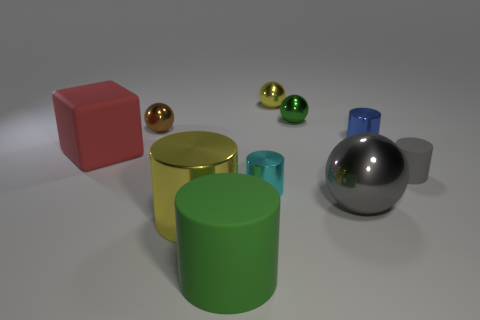How do the shadows cast by the objects inform us about the light source? The shadows extend to the right of the objects, indicating that the light source is positioned to the left of the scene. The softness and length of the shadows suggest a single diffused light source, not too close to the objects, possibly mimicking an overcast sky or a softbox in photography. 